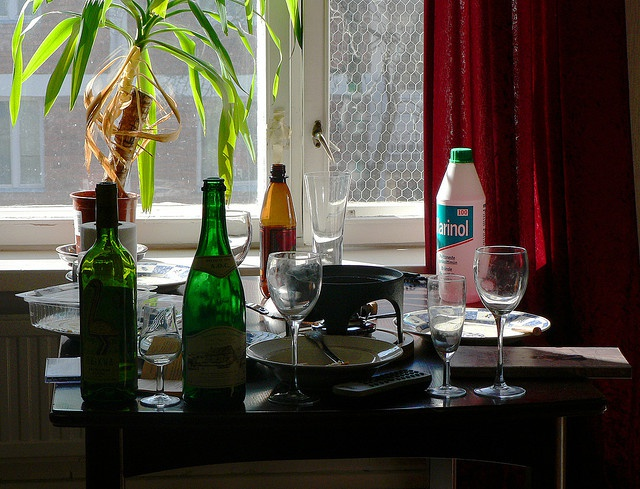Describe the objects in this image and their specific colors. I can see dining table in darkgray, black, gray, and white tones, potted plant in darkgray, olive, and lime tones, bottle in darkgray, black, darkgreen, and green tones, bottle in darkgray, black, darkgreen, and gray tones, and bowl in darkgray, black, gray, and darkgreen tones in this image. 